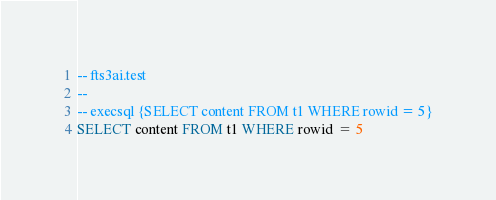<code> <loc_0><loc_0><loc_500><loc_500><_SQL_>-- fts3ai.test
-- 
-- execsql {SELECT content FROM t1 WHERE rowid = 5}
SELECT content FROM t1 WHERE rowid = 5</code> 